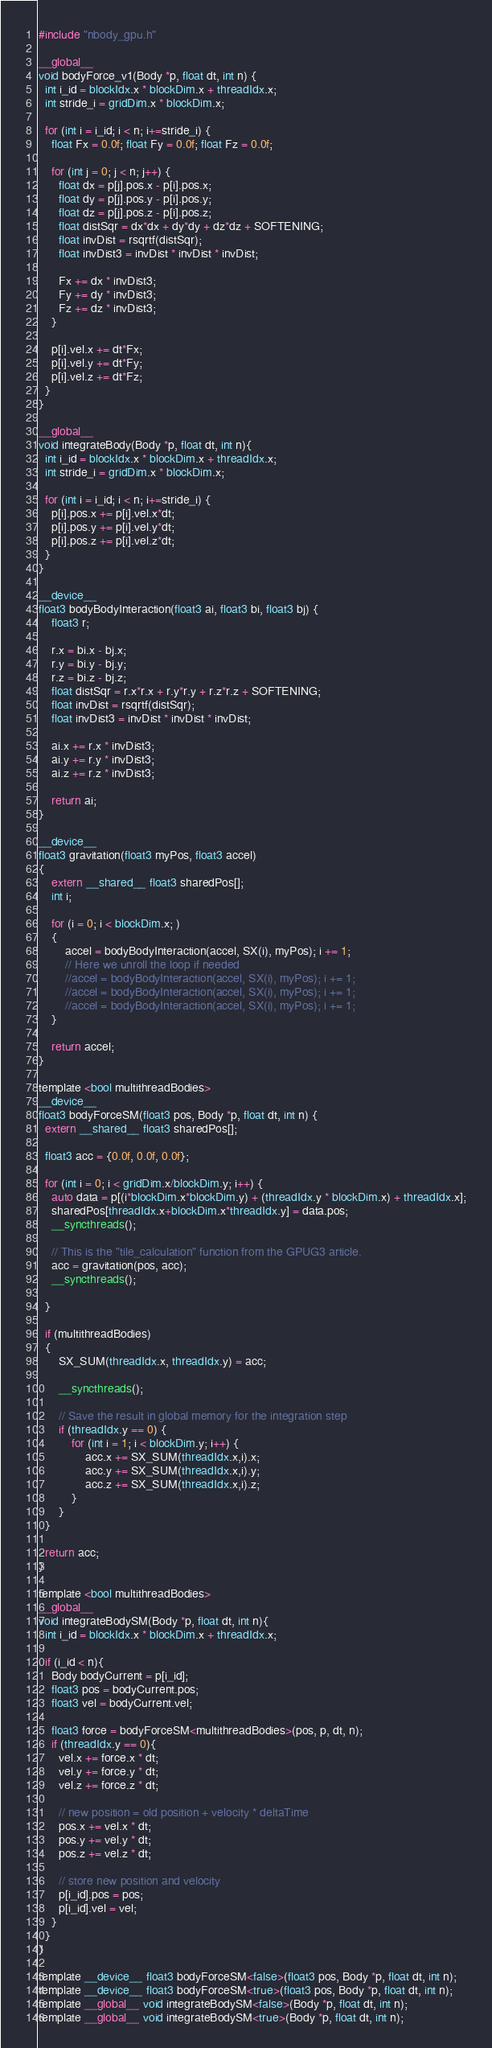Convert code to text. <code><loc_0><loc_0><loc_500><loc_500><_Cuda_>#include "nbody_gpu.h"

__global__
void bodyForce_v1(Body *p, float dt, int n) {
  int i_id = blockIdx.x * blockDim.x + threadIdx.x;
  int stride_i = gridDim.x * blockDim.x;
  
  for (int i = i_id; i < n; i+=stride_i) {
    float Fx = 0.0f; float Fy = 0.0f; float Fz = 0.0f;

    for (int j = 0; j < n; j++) {
      float dx = p[j].pos.x - p[i].pos.x;
      float dy = p[j].pos.y - p[i].pos.y;
      float dz = p[j].pos.z - p[i].pos.z;
      float distSqr = dx*dx + dy*dy + dz*dz + SOFTENING;
      float invDist = rsqrtf(distSqr);
      float invDist3 = invDist * invDist * invDist;      

      Fx += dx * invDist3; 
      Fy += dy * invDist3; 
      Fz += dz * invDist3;
    }
    
    p[i].vel.x += dt*Fx; 
    p[i].vel.y += dt*Fy; 
    p[i].vel.z += dt*Fz;
  }
}

__global__
void integrateBody(Body *p, float dt, int n){
  int i_id = blockIdx.x * blockDim.x + threadIdx.x;
  int stride_i = gridDim.x * blockDim.x;
  
  for (int i = i_id; i < n; i+=stride_i) {
    p[i].pos.x += p[i].vel.x*dt;
    p[i].pos.y += p[i].vel.y*dt;
    p[i].pos.z += p[i].vel.z*dt;
  }
}

__device__ 
float3 bodyBodyInteraction(float3 ai, float3 bi, float3 bj) {
    float3 r;

    r.x = bi.x - bj.x;
    r.y = bi.y - bj.y;
    r.z = bi.z - bj.z;
    float distSqr = r.x*r.x + r.y*r.y + r.z*r.z + SOFTENING;
    float invDist = rsqrtf(distSqr);
    float invDist3 = invDist * invDist * invDist;      

    ai.x += r.x * invDist3;
    ai.y += r.y * invDist3;
    ai.z += r.z * invDist3;

    return ai;
}

__device__ 
float3 gravitation(float3 myPos, float3 accel)
{
    extern __shared__ float3 sharedPos[];
    int i;

    for (i = 0; i < blockDim.x; ) 
    {
        accel = bodyBodyInteraction(accel, SX(i), myPos); i += 1;
        // Here we unroll the loop if needed
        //accel = bodyBodyInteraction(accel, SX(i), myPos); i += 1;
        //accel = bodyBodyInteraction(accel, SX(i), myPos); i += 1;
        //accel = bodyBodyInteraction(accel, SX(i), myPos); i += 1;
    }

    return accel;
}

template <bool multithreadBodies>
__device__
float3 bodyForceSM(float3 pos, Body *p, float dt, int n) {
  extern __shared__ float3 sharedPos[];
  
  float3 acc = {0.0f, 0.0f, 0.0f};
  
  for (int i = 0; i < gridDim.x/blockDim.y; i++) {
    auto data = p[(i*blockDim.x*blockDim.y) + (threadIdx.y * blockDim.x) + threadIdx.x];
    sharedPos[threadIdx.x+blockDim.x*threadIdx.y] = data.pos;
    __syncthreads();

    // This is the "tile_calculation" function from the GPUG3 article.
    acc = gravitation(pos, acc);
    __syncthreads();
    
  }

  if (multithreadBodies)
  {
      SX_SUM(threadIdx.x, threadIdx.y) = acc;

      __syncthreads();

      // Save the result in global memory for the integration step
      if (threadIdx.y == 0) {
          for (int i = 1; i < blockDim.y; i++) {
              acc.x += SX_SUM(threadIdx.x,i).x;
              acc.y += SX_SUM(threadIdx.x,i).y;
              acc.z += SX_SUM(threadIdx.x,i).z;
          }
      }
  }

  return acc;
}

template <bool multithreadBodies>
__global__
void integrateBodySM(Body *p, float dt, int n){
  int i_id = blockIdx.x * blockDim.x + threadIdx.x;
  
  if (i_id < n){
    Body bodyCurrent = p[i_id];   
    float3 pos = bodyCurrent.pos;
    float3 vel = bodyCurrent.vel;
    
    float3 force = bodyForceSM<multithreadBodies>(pos, p, dt, n);    
    if (threadIdx.y == 0){
      vel.x += force.x * dt;
      vel.y += force.y * dt;
      vel.z += force.z * dt;  
          
      // new position = old position + velocity * deltaTime
      pos.x += vel.x * dt;
      pos.y += vel.y * dt;
      pos.z += vel.z * dt;

      // store new position and velocity
      p[i_id].pos = pos;
      p[i_id].vel = vel;
    }
  }
}

template __device__ float3 bodyForceSM<false>(float3 pos, Body *p, float dt, int n);
template __device__ float3 bodyForceSM<true>(float3 pos, Body *p, float dt, int n);
template __global__ void integrateBodySM<false>(Body *p, float dt, int n);
template __global__ void integrateBodySM<true>(Body *p, float dt, int n);</code> 